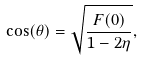<formula> <loc_0><loc_0><loc_500><loc_500>\cos ( \theta ) = \sqrt { \frac { F ( 0 ) } { 1 - 2 \eta } } ,</formula> 